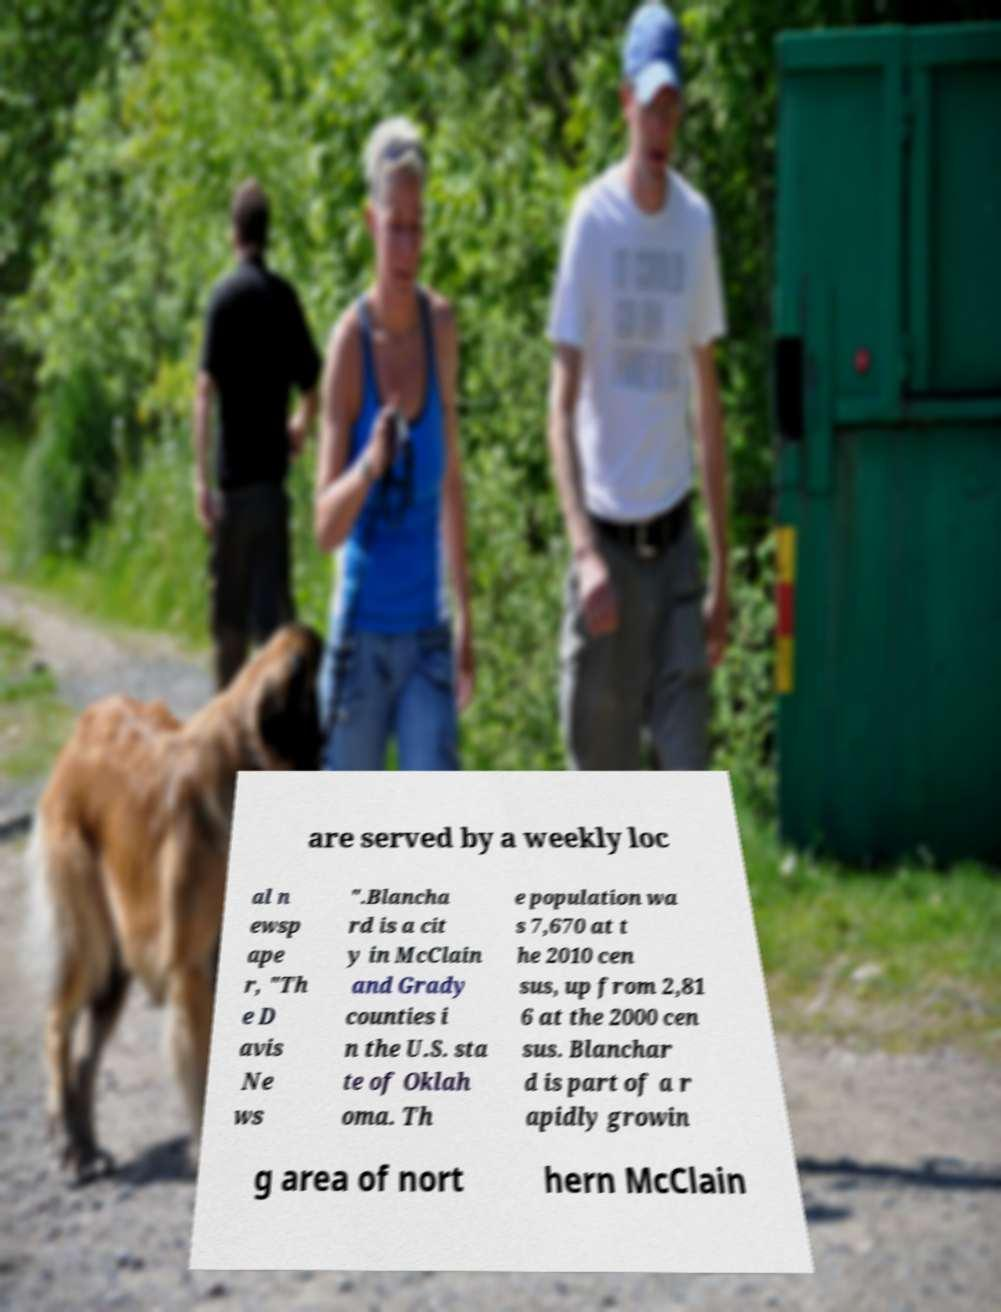Please read and relay the text visible in this image. What does it say? are served by a weekly loc al n ewsp ape r, "Th e D avis Ne ws ".Blancha rd is a cit y in McClain and Grady counties i n the U.S. sta te of Oklah oma. Th e population wa s 7,670 at t he 2010 cen sus, up from 2,81 6 at the 2000 cen sus. Blanchar d is part of a r apidly growin g area of nort hern McClain 